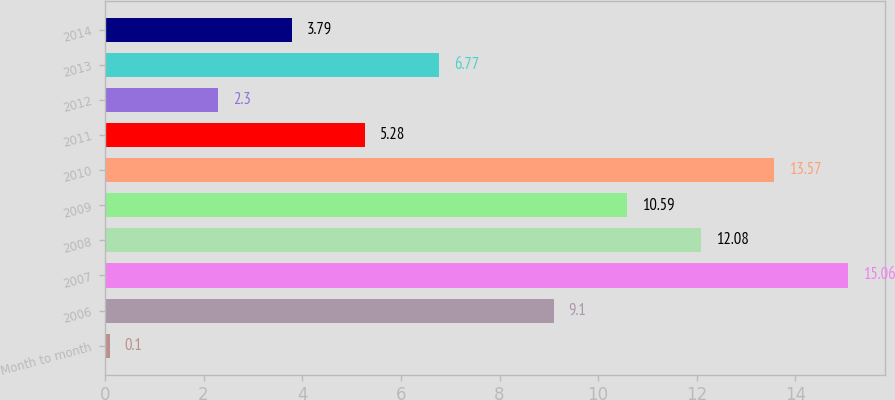Convert chart. <chart><loc_0><loc_0><loc_500><loc_500><bar_chart><fcel>Month to month<fcel>2006<fcel>2007<fcel>2008<fcel>2009<fcel>2010<fcel>2011<fcel>2012<fcel>2013<fcel>2014<nl><fcel>0.1<fcel>9.1<fcel>15.06<fcel>12.08<fcel>10.59<fcel>13.57<fcel>5.28<fcel>2.3<fcel>6.77<fcel>3.79<nl></chart> 